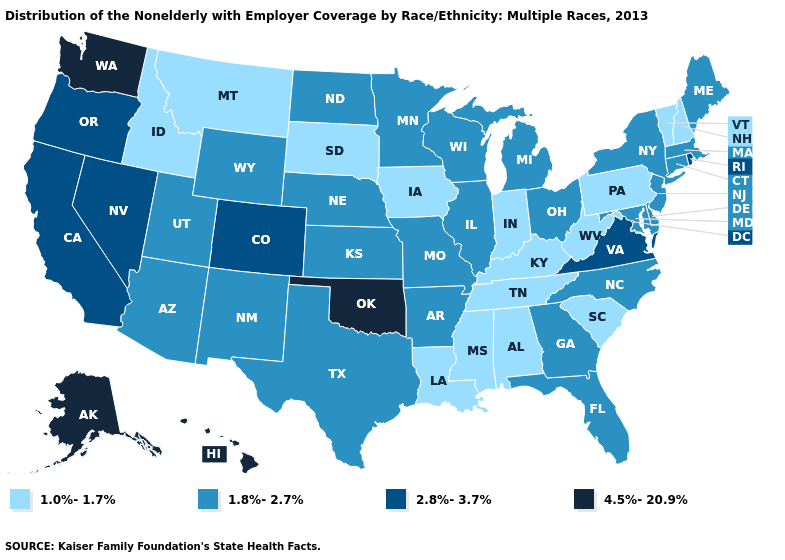Does Washington have the highest value in the USA?
Be succinct. Yes. Name the states that have a value in the range 2.8%-3.7%?
Answer briefly. California, Colorado, Nevada, Oregon, Rhode Island, Virginia. What is the value of Vermont?
Short answer required. 1.0%-1.7%. Name the states that have a value in the range 1.8%-2.7%?
Short answer required. Arizona, Arkansas, Connecticut, Delaware, Florida, Georgia, Illinois, Kansas, Maine, Maryland, Massachusetts, Michigan, Minnesota, Missouri, Nebraska, New Jersey, New Mexico, New York, North Carolina, North Dakota, Ohio, Texas, Utah, Wisconsin, Wyoming. Name the states that have a value in the range 1.8%-2.7%?
Write a very short answer. Arizona, Arkansas, Connecticut, Delaware, Florida, Georgia, Illinois, Kansas, Maine, Maryland, Massachusetts, Michigan, Minnesota, Missouri, Nebraska, New Jersey, New Mexico, New York, North Carolina, North Dakota, Ohio, Texas, Utah, Wisconsin, Wyoming. Does Michigan have the highest value in the USA?
Give a very brief answer. No. What is the highest value in the South ?
Give a very brief answer. 4.5%-20.9%. Is the legend a continuous bar?
Be succinct. No. What is the lowest value in the USA?
Concise answer only. 1.0%-1.7%. What is the lowest value in the USA?
Keep it brief. 1.0%-1.7%. Which states have the lowest value in the West?
Short answer required. Idaho, Montana. Name the states that have a value in the range 2.8%-3.7%?
Concise answer only. California, Colorado, Nevada, Oregon, Rhode Island, Virginia. Is the legend a continuous bar?
Keep it brief. No. What is the value of Delaware?
Answer briefly. 1.8%-2.7%. 